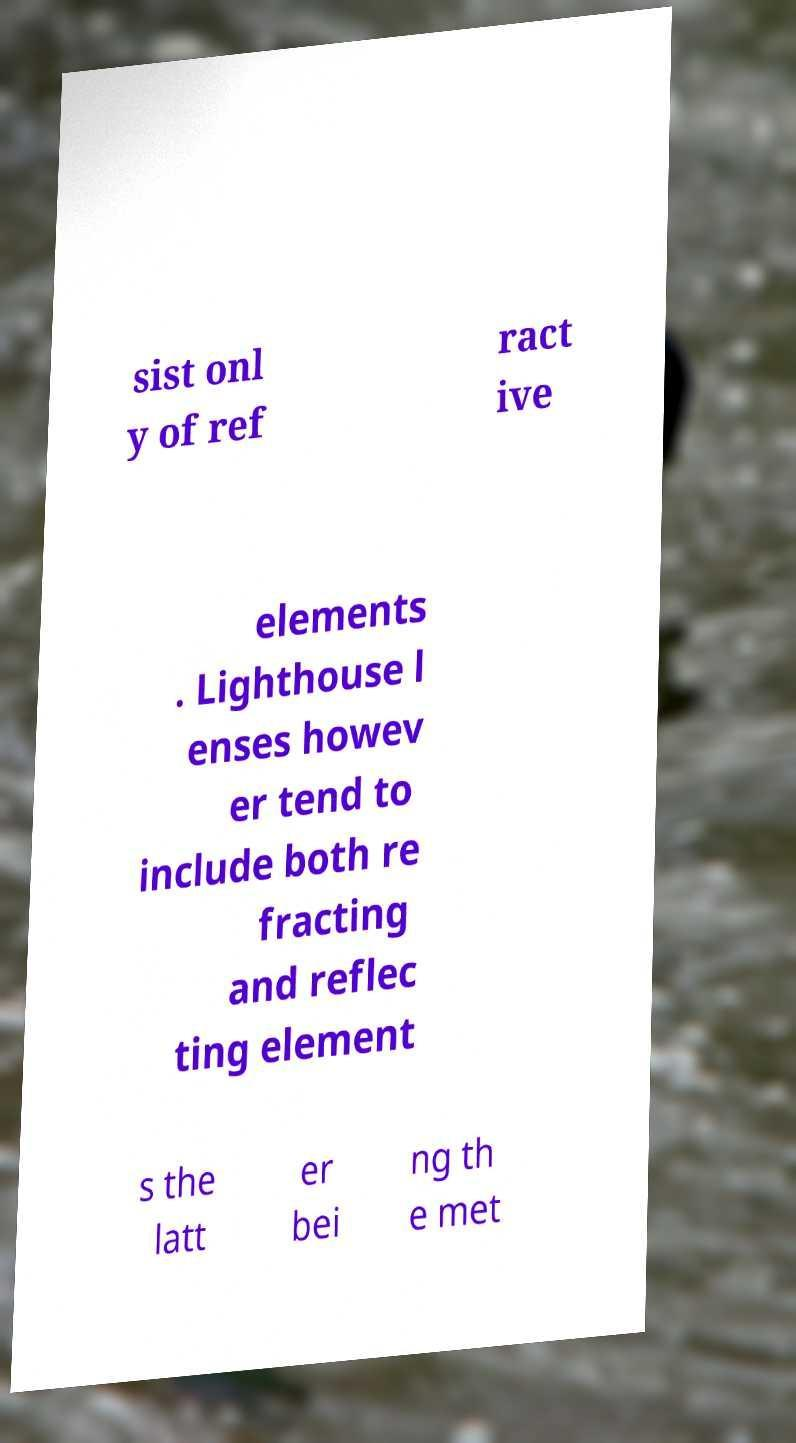What messages or text are displayed in this image? I need them in a readable, typed format. sist onl y of ref ract ive elements . Lighthouse l enses howev er tend to include both re fracting and reflec ting element s the latt er bei ng th e met 